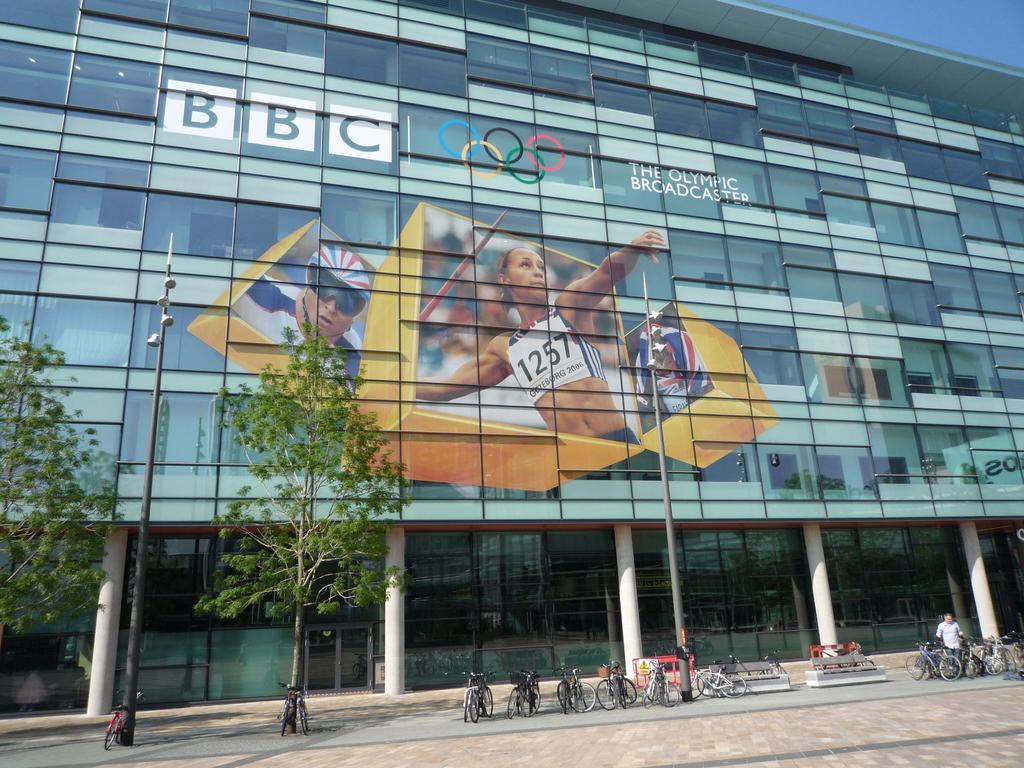Please provide a concise description of this image. In this image we can see a building with pillars. We can also see some pictures, text and a logo on the building. On the bottom of the image we can see some trees, a group of bicycles parked on the footpath, some poles, benches and a person standing. On the backside we can see the sky. 